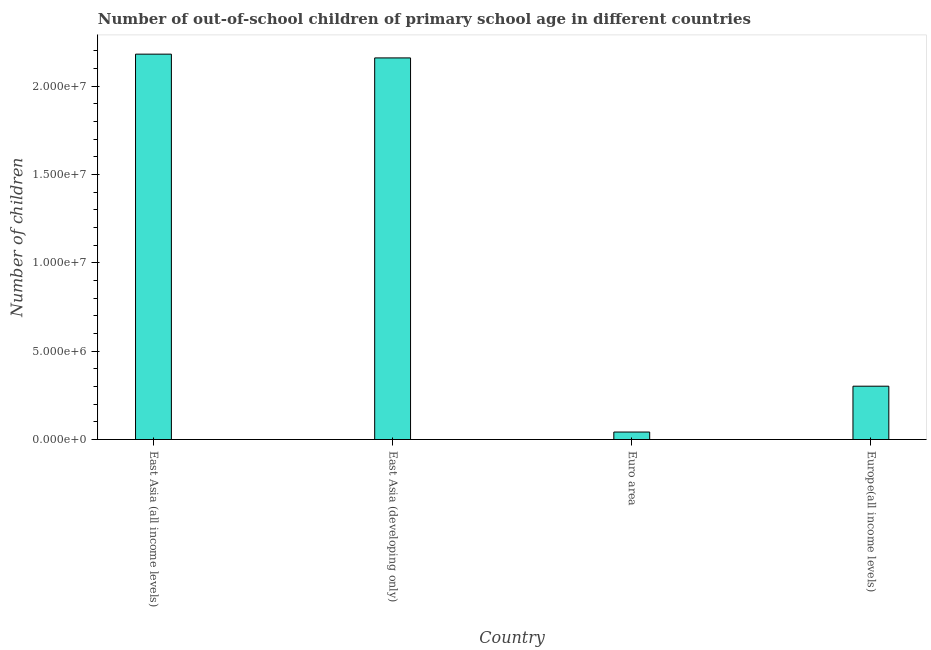Does the graph contain any zero values?
Your response must be concise. No. What is the title of the graph?
Keep it short and to the point. Number of out-of-school children of primary school age in different countries. What is the label or title of the Y-axis?
Keep it short and to the point. Number of children. What is the number of out-of-school children in East Asia (developing only)?
Your answer should be very brief. 2.16e+07. Across all countries, what is the maximum number of out-of-school children?
Your response must be concise. 2.18e+07. Across all countries, what is the minimum number of out-of-school children?
Your answer should be very brief. 4.23e+05. In which country was the number of out-of-school children maximum?
Provide a succinct answer. East Asia (all income levels). What is the sum of the number of out-of-school children?
Offer a very short reply. 4.69e+07. What is the difference between the number of out-of-school children in East Asia (developing only) and Euro area?
Provide a short and direct response. 2.12e+07. What is the average number of out-of-school children per country?
Give a very brief answer. 1.17e+07. What is the median number of out-of-school children?
Your response must be concise. 1.23e+07. In how many countries, is the number of out-of-school children greater than 18000000 ?
Give a very brief answer. 2. What is the ratio of the number of out-of-school children in East Asia (developing only) to that in Europe(all income levels)?
Give a very brief answer. 7.16. Is the difference between the number of out-of-school children in East Asia (all income levels) and Euro area greater than the difference between any two countries?
Give a very brief answer. Yes. What is the difference between the highest and the second highest number of out-of-school children?
Provide a short and direct response. 2.14e+05. Is the sum of the number of out-of-school children in East Asia (all income levels) and East Asia (developing only) greater than the maximum number of out-of-school children across all countries?
Keep it short and to the point. Yes. What is the difference between the highest and the lowest number of out-of-school children?
Provide a succinct answer. 2.14e+07. How many bars are there?
Your answer should be very brief. 4. Are all the bars in the graph horizontal?
Ensure brevity in your answer.  No. Are the values on the major ticks of Y-axis written in scientific E-notation?
Give a very brief answer. Yes. What is the Number of children in East Asia (all income levels)?
Make the answer very short. 2.18e+07. What is the Number of children of East Asia (developing only)?
Your answer should be very brief. 2.16e+07. What is the Number of children in Euro area?
Ensure brevity in your answer.  4.23e+05. What is the Number of children in Europe(all income levels)?
Provide a succinct answer. 3.02e+06. What is the difference between the Number of children in East Asia (all income levels) and East Asia (developing only)?
Offer a very short reply. 2.14e+05. What is the difference between the Number of children in East Asia (all income levels) and Euro area?
Make the answer very short. 2.14e+07. What is the difference between the Number of children in East Asia (all income levels) and Europe(all income levels)?
Provide a succinct answer. 1.88e+07. What is the difference between the Number of children in East Asia (developing only) and Euro area?
Your answer should be very brief. 2.12e+07. What is the difference between the Number of children in East Asia (developing only) and Europe(all income levels)?
Keep it short and to the point. 1.86e+07. What is the difference between the Number of children in Euro area and Europe(all income levels)?
Offer a very short reply. -2.60e+06. What is the ratio of the Number of children in East Asia (all income levels) to that in Euro area?
Offer a terse response. 51.54. What is the ratio of the Number of children in East Asia (all income levels) to that in Europe(all income levels)?
Your answer should be very brief. 7.23. What is the ratio of the Number of children in East Asia (developing only) to that in Euro area?
Offer a very short reply. 51.04. What is the ratio of the Number of children in East Asia (developing only) to that in Europe(all income levels)?
Your response must be concise. 7.16. What is the ratio of the Number of children in Euro area to that in Europe(all income levels)?
Make the answer very short. 0.14. 